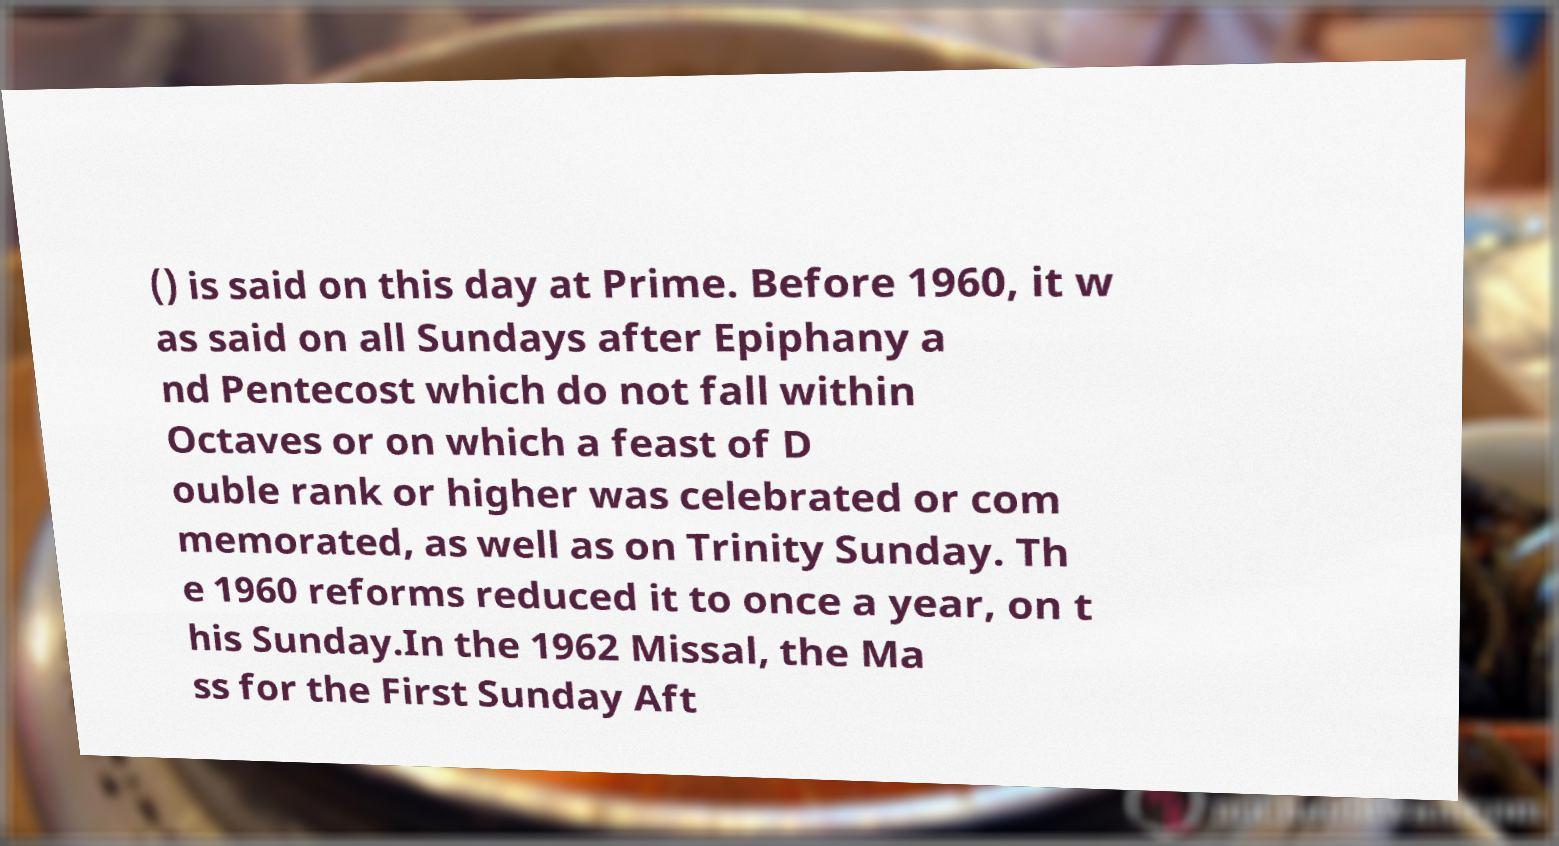What messages or text are displayed in this image? I need them in a readable, typed format. () is said on this day at Prime. Before 1960, it w as said on all Sundays after Epiphany a nd Pentecost which do not fall within Octaves or on which a feast of D ouble rank or higher was celebrated or com memorated, as well as on Trinity Sunday. Th e 1960 reforms reduced it to once a year, on t his Sunday.In the 1962 Missal, the Ma ss for the First Sunday Aft 